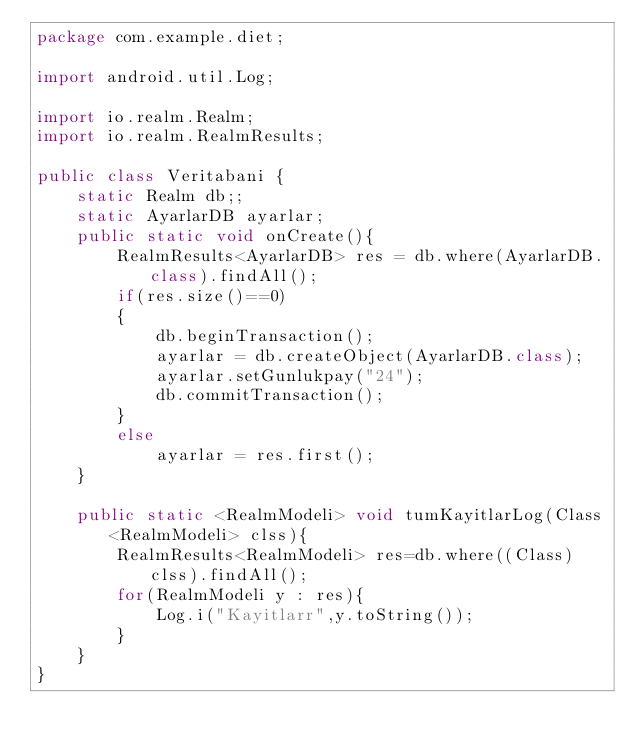<code> <loc_0><loc_0><loc_500><loc_500><_Java_>package com.example.diet;

import android.util.Log;

import io.realm.Realm;
import io.realm.RealmResults;

public class Veritabani {
    static Realm db;;
    static AyarlarDB ayarlar;
    public static void onCreate(){
        RealmResults<AyarlarDB> res = db.where(AyarlarDB.class).findAll();
        if(res.size()==0)
        {
            db.beginTransaction();
            ayarlar = db.createObject(AyarlarDB.class);
            ayarlar.setGunlukpay("24");
            db.commitTransaction();
        }
        else
            ayarlar = res.first();
    }

    public static <RealmModeli> void tumKayitlarLog(Class<RealmModeli> clss){
        RealmResults<RealmModeli> res=db.where((Class) clss).findAll();
        for(RealmModeli y : res){
            Log.i("Kayitlarr",y.toString());
        }
    }
}
</code> 